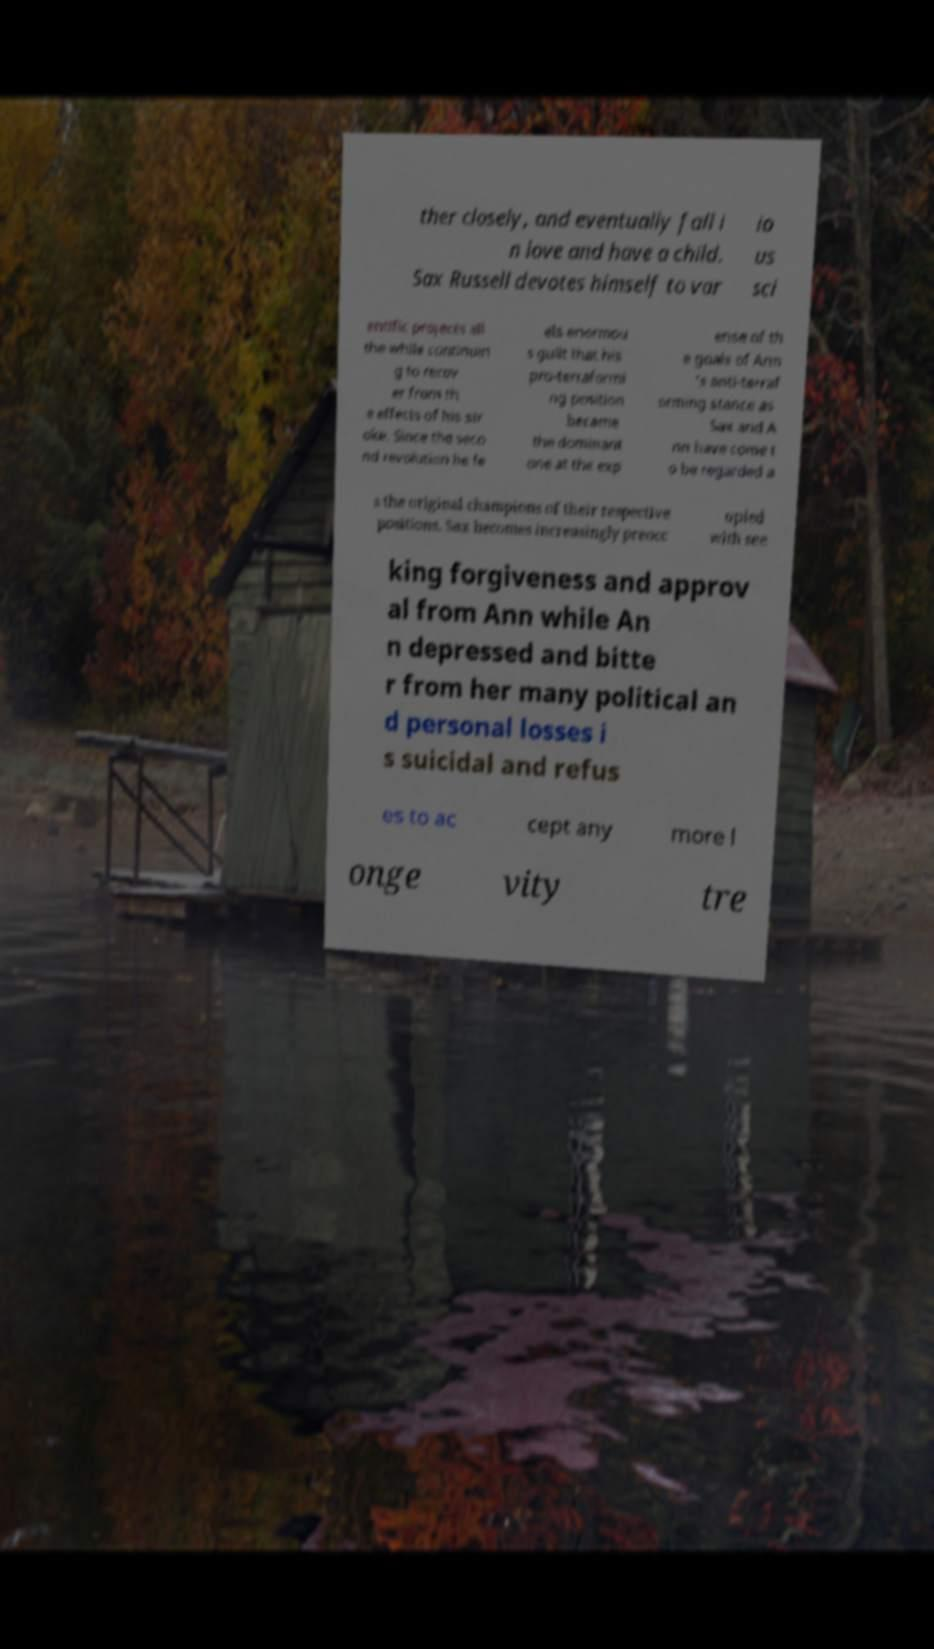Could you extract and type out the text from this image? ther closely, and eventually fall i n love and have a child. Sax Russell devotes himself to var io us sci entific projects all the while continuin g to recov er from th e effects of his str oke. Since the seco nd revolution he fe els enormou s guilt that his pro-terraformi ng position became the dominant one at the exp ense of th e goals of Ann 's anti-terraf orming stance as Sax and A nn have come t o be regarded a s the original champions of their respective positions. Sax becomes increasingly preocc upied with see king forgiveness and approv al from Ann while An n depressed and bitte r from her many political an d personal losses i s suicidal and refus es to ac cept any more l onge vity tre 